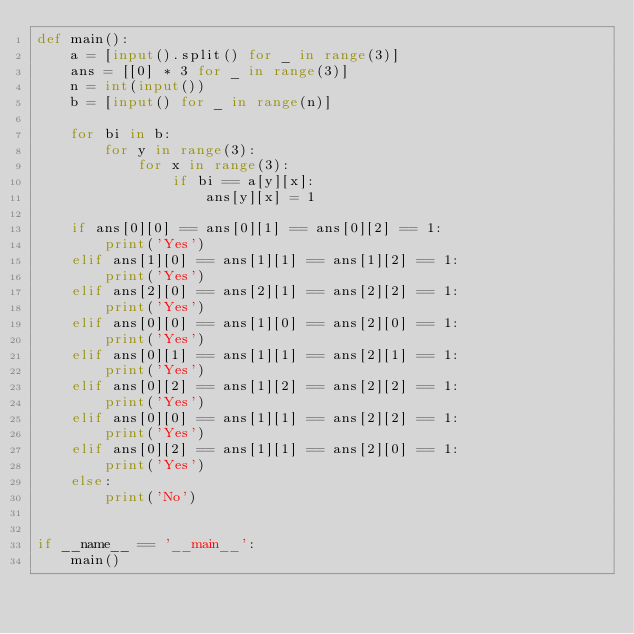Convert code to text. <code><loc_0><loc_0><loc_500><loc_500><_Python_>def main():
    a = [input().split() for _ in range(3)]
    ans = [[0] * 3 for _ in range(3)]
    n = int(input())
    b = [input() for _ in range(n)]

    for bi in b:
        for y in range(3):
            for x in range(3):
                if bi == a[y][x]:
                    ans[y][x] = 1

    if ans[0][0] == ans[0][1] == ans[0][2] == 1:
        print('Yes')
    elif ans[1][0] == ans[1][1] == ans[1][2] == 1:
        print('Yes')
    elif ans[2][0] == ans[2][1] == ans[2][2] == 1:
        print('Yes')
    elif ans[0][0] == ans[1][0] == ans[2][0] == 1:
        print('Yes')
    elif ans[0][1] == ans[1][1] == ans[2][1] == 1:
        print('Yes')
    elif ans[0][2] == ans[1][2] == ans[2][2] == 1:
        print('Yes')
    elif ans[0][0] == ans[1][1] == ans[2][2] == 1:
        print('Yes')
    elif ans[0][2] == ans[1][1] == ans[2][0] == 1:
        print('Yes')
    else:
        print('No')


if __name__ == '__main__':
    main()

</code> 